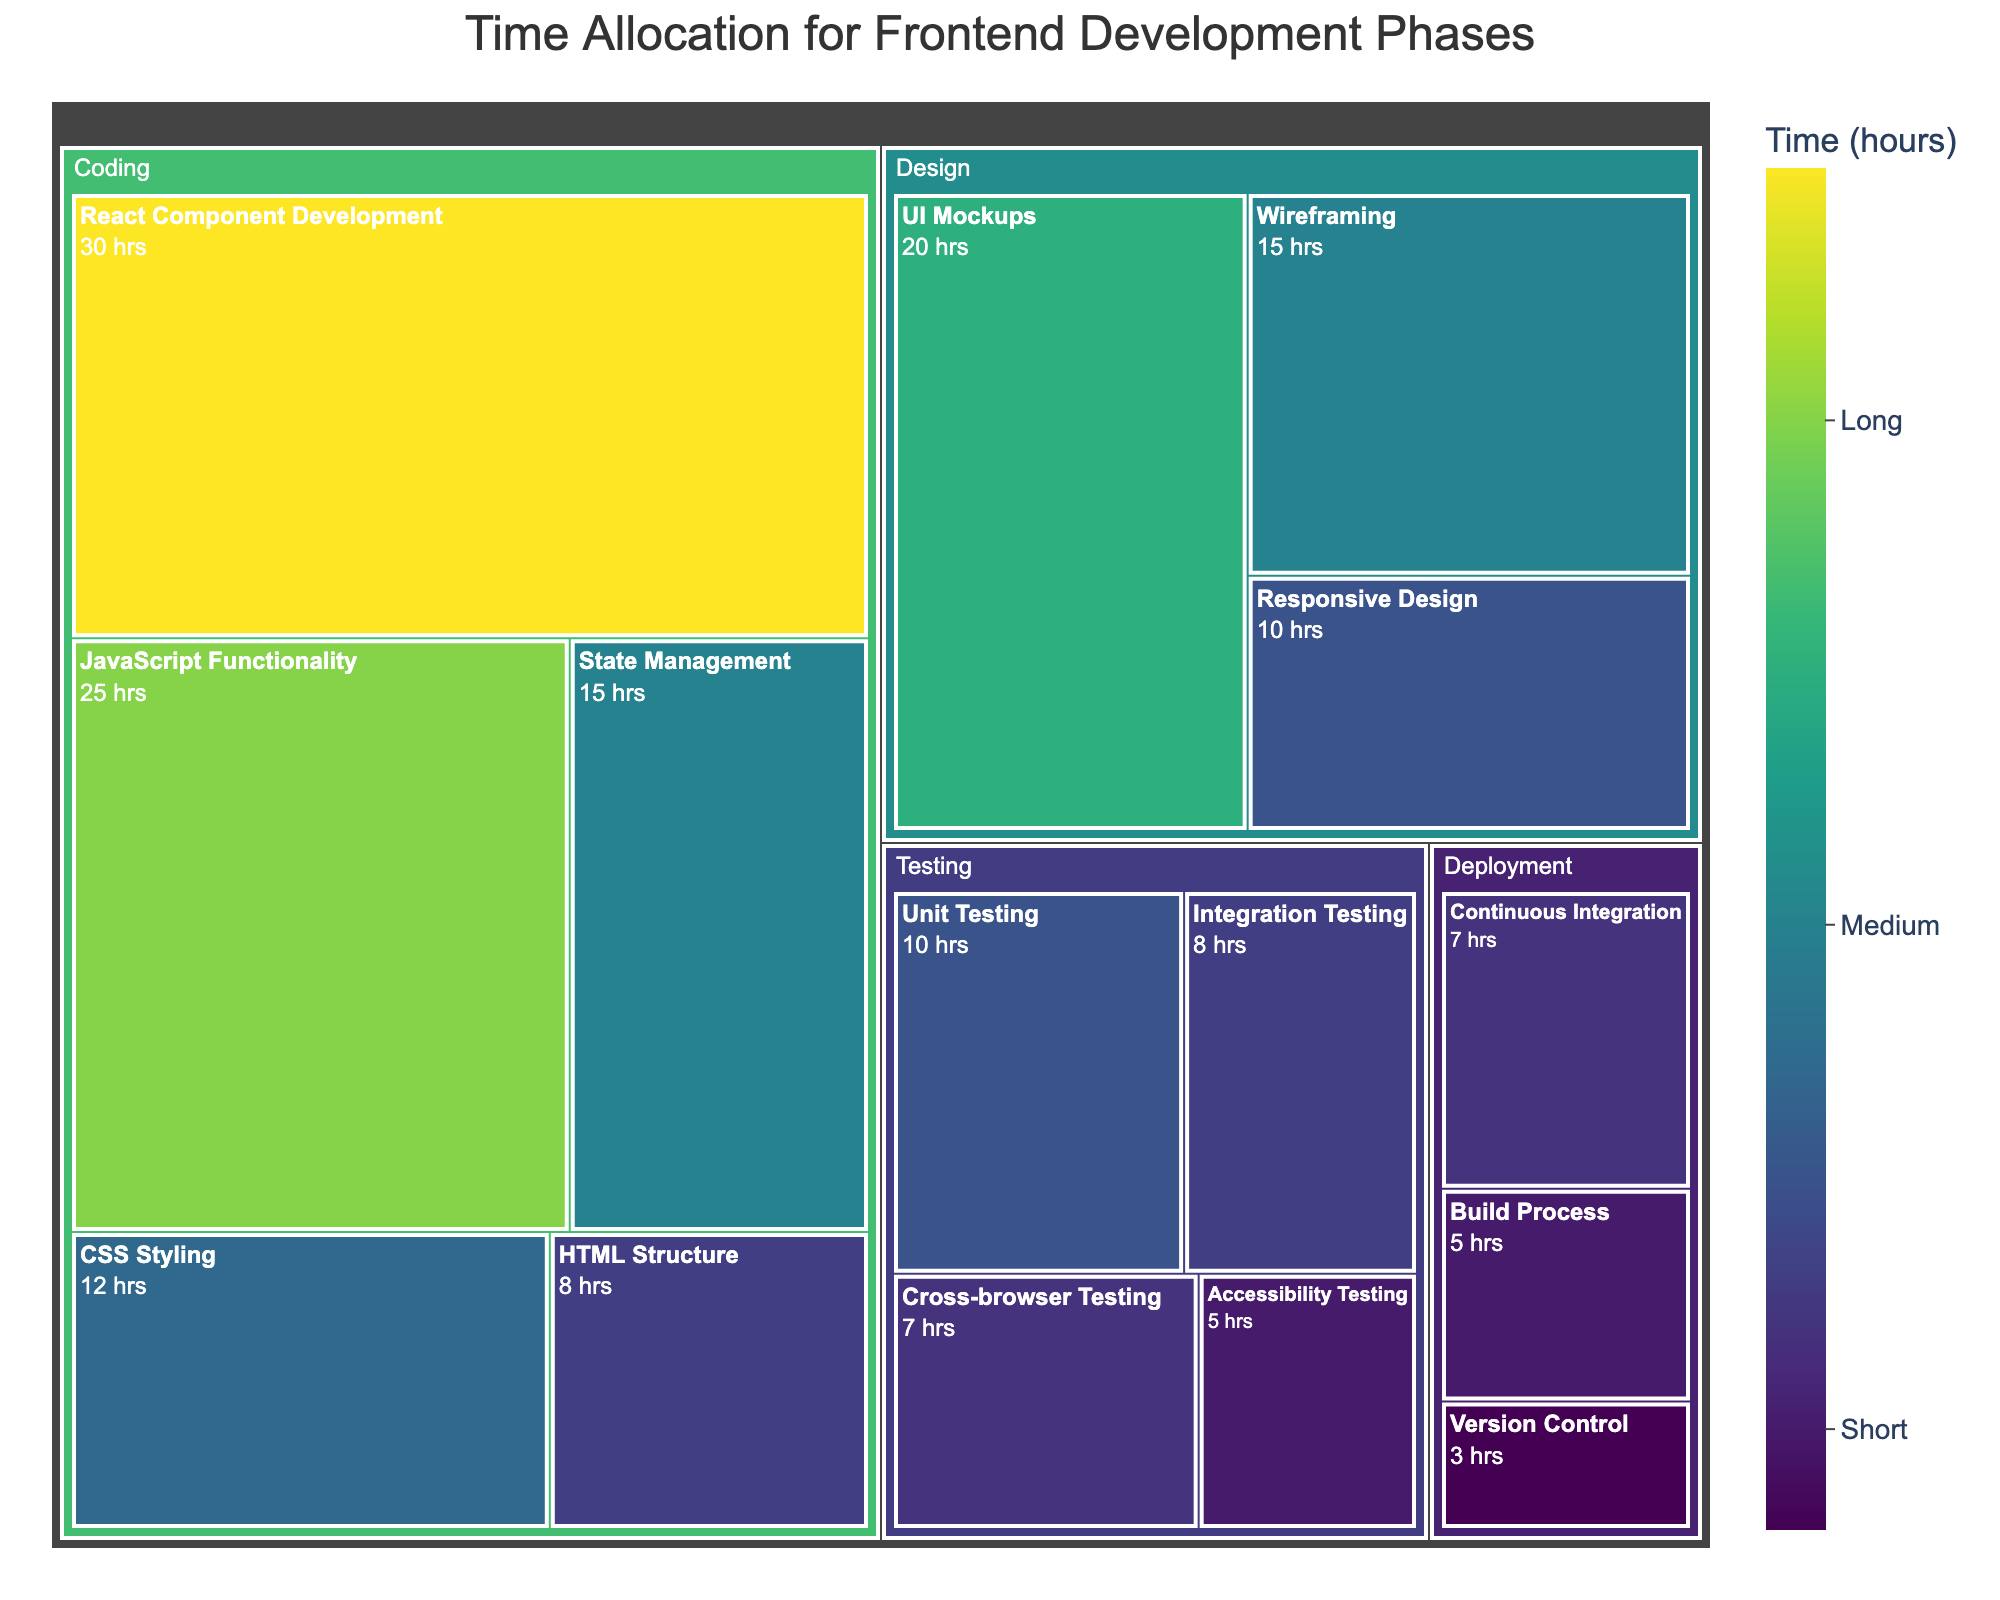what is the total time allocated for the Coding phase? Sum all the time allocated for the Coding subphases including HTML Structure (8), CSS Styling (12), JavaScript Functionality (25), React Component Development (30), and State Management (15). 8 + 12 + 25 + 30 + 15 = 90 hours
Answer: 90 hours Which subphase under the Design phase has the highest time allocation? Compare the time allocated to each subphase under the Design phase: Wireframing (15), UI Mockups (20), and Responsive Design (10). The subphase with the highest time allocation is UI Mockups with 20 hours
Answer: UI Mockups How much more time is spent on React Component Development compared to Continuous Integration? React Component Development takes 30 hours and Continuous Integration takes 7 hours. The difference between them is 30 - 7 = 23 hours
Answer: 23 hours What phase has the least total time allocation? Summing the time allocations for each phase, we have: Design (45), Coding (90), Testing (30), Deployment (15). The phase with the least time allocation is Deployment with 15 hours
Answer: Deployment What is the total time allocated for testing? Sum all the time allocated for testing subphases: Unit Testing (10), Integration Testing (8), Cross-browser Testing (7), Accessibility Testing (5). 10 + 8 + 7 + 5 = 30 hours
Answer: 30 hours Which phase has the largest time allocation? Sum the time allocated for each phase: Design (45), Coding (90), Testing (30), Deployment (15). The phase with the largest time allocation is Coding with 90 hours
Answer: Coding How much total time is spent on activities involving user interface design? Sum the time allocated for relevant subphases: UI Mockups (20), Responsive Design (10). 20 + 10 = 30 hours
Answer: 30 hours What is the average time allocated per subphase in the Coding phase? There are 5 subphases in Coding: HTML Structure (8), CSS Styling (12), JavaScript Functionality (25), React Component Development (30), State Management (15). The total time is 90 hours. The average time is 90 / 5 = 18 hours
Answer: 18 hours Which subphase in the Testing phase has the least time allocation? Comparing the time allocated to each subphase in the Testing phase: Unit Testing (10), Integration Testing (8), Cross-browser Testing (7), Accessibility Testing (5). The subphase with the least time allocation is Accessibility Testing with 5 hours
Answer: Accessibility Testing 